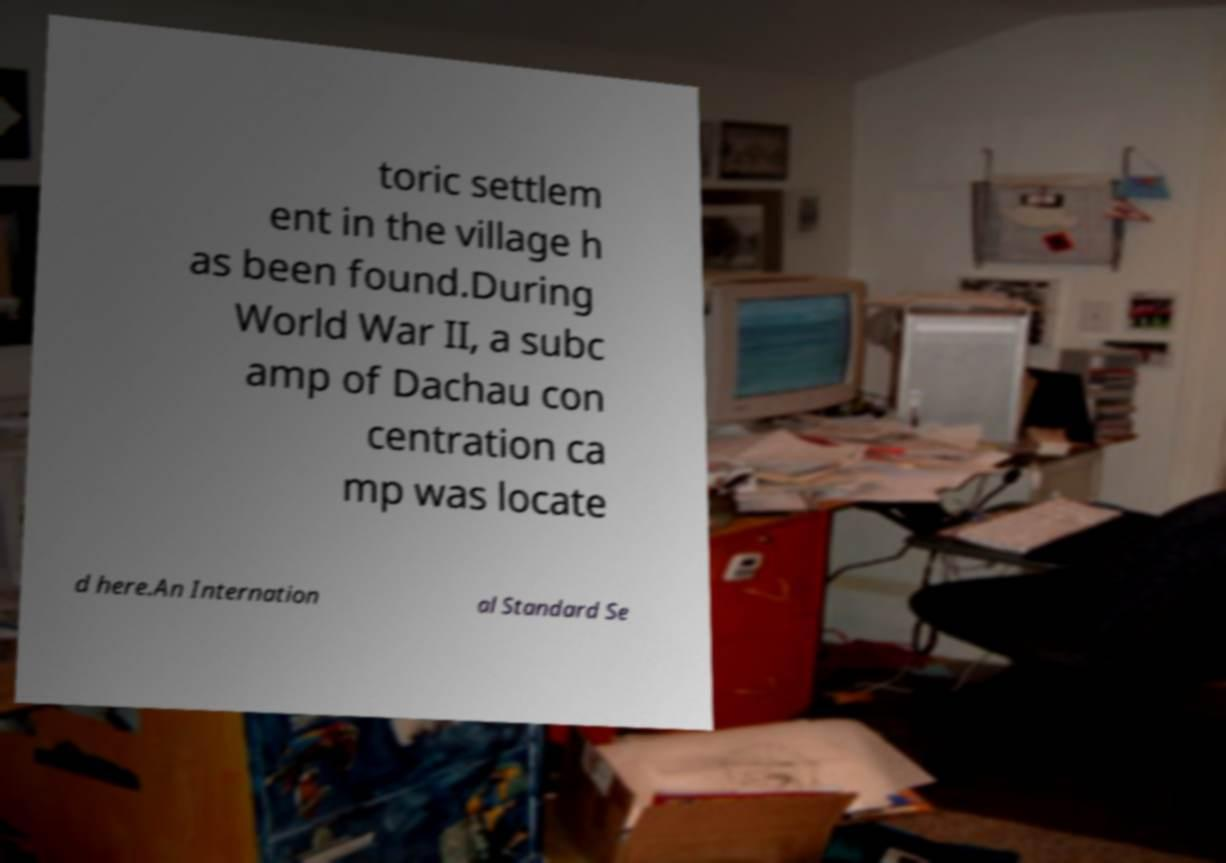Please identify and transcribe the text found in this image. toric settlem ent in the village h as been found.During World War II, a subc amp of Dachau con centration ca mp was locate d here.An Internation al Standard Se 